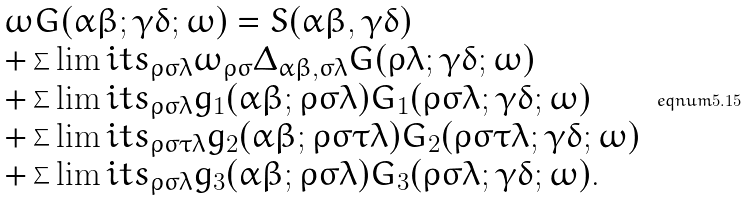Convert formula to latex. <formula><loc_0><loc_0><loc_500><loc_500>\begin{array} { l } \omega G ( \alpha \beta ; \gamma \delta ; \omega ) = S ( \alpha \beta , \gamma \delta ) \\ + \sum \lim i t s _ { \rho \sigma \lambda } \omega _ { \rho \sigma } \Delta _ { \alpha \beta , \sigma \lambda } G ( \rho \lambda ; \gamma \delta ; \omega ) \\ + \sum \lim i t s _ { \rho \sigma \lambda } g _ { 1 } ( \alpha \beta ; \rho \sigma \lambda ) G _ { 1 } ( \rho \sigma \lambda ; \gamma \delta ; \omega ) \\ + \sum \lim i t s _ { \rho \sigma \tau \lambda } g _ { 2 } ( \alpha \beta ; \rho \sigma \tau \lambda ) G _ { 2 } ( \rho \sigma \tau \lambda ; \gamma \delta ; \omega ) \\ + \sum \lim i t s _ { \rho \sigma \lambda } g _ { 3 } ( \alpha \beta ; \rho \sigma \lambda ) G _ { 3 } ( \rho \sigma \lambda ; \gamma \delta ; \omega ) . \end{array} \ e q n u m { 5 . 1 5 }</formula> 